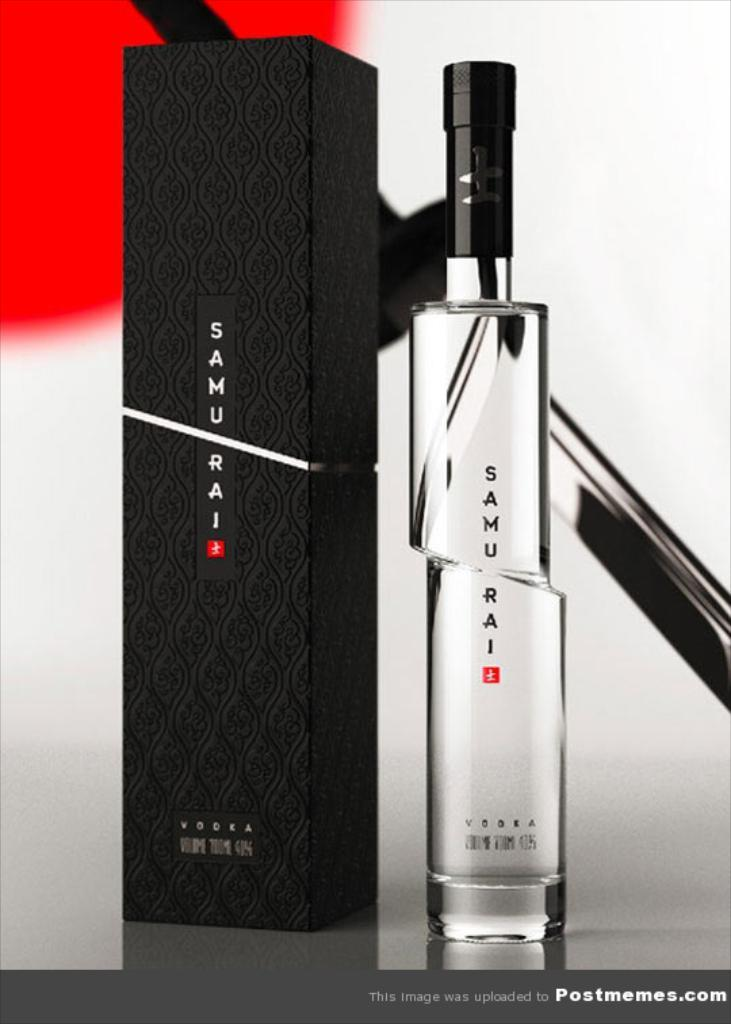<image>
Offer a succinct explanation of the picture presented. A bottle of Samurai perfume sits near the black box it came in. 